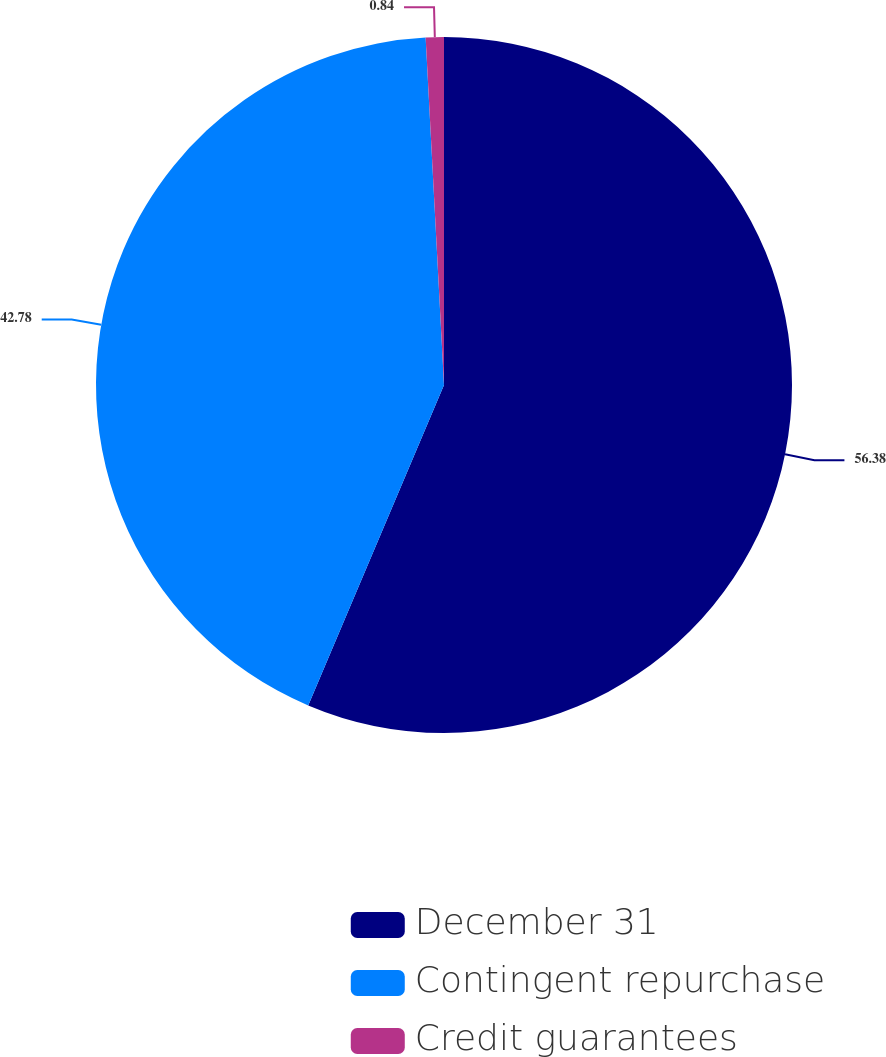Convert chart. <chart><loc_0><loc_0><loc_500><loc_500><pie_chart><fcel>December 31<fcel>Contingent repurchase<fcel>Credit guarantees<nl><fcel>56.38%<fcel>42.78%<fcel>0.84%<nl></chart> 